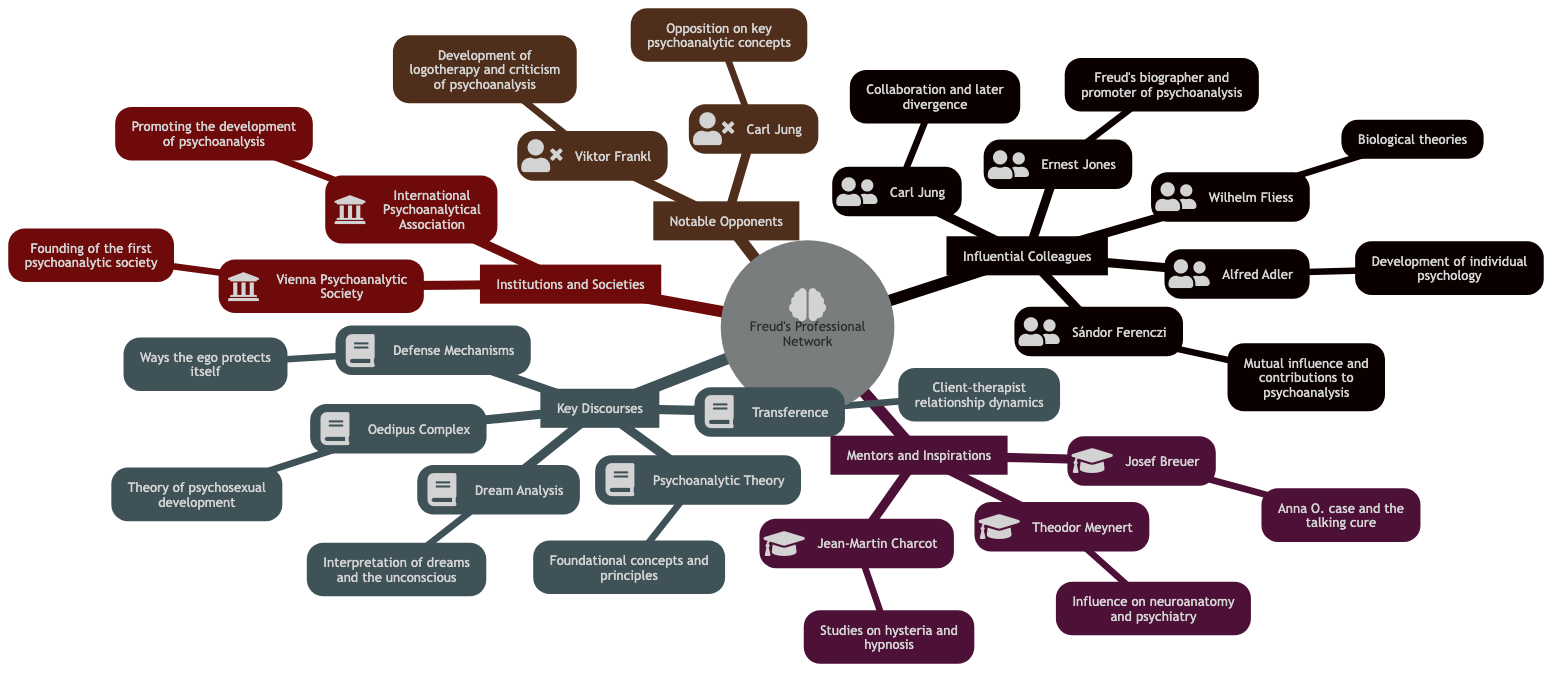What are the main topics in Freud's Professional Network? The main topics in the mind map are "Influential Colleagues," "Mentors and Inspirations," "Key Discourses," "Notable Opponents," and "Institutions and Societies." Each of these subtopics is connected to Freud's professional life, highlighting different aspects of his network.
Answer: Influential Colleagues, Mentors and Inspirations, Key Discourses, Notable Opponents, Institutions and Societies Who is described as Freud's biographer and promoter of psychoanalysis? In the "Influential Colleagues" section, the element describing Freud's biographer and promoter is Ernest Jones, which clearly states this role in the context provided.
Answer: Ernest Jones How many mentors are listed in Freud's Professional Network? Counting the elements in the "Mentors and Inspirations" section, there are three notable figures mentioned: Jean-Martin Charcot, Josef Breuer, and Theodor Meynert. Summing these gives a total count of three mentors.
Answer: 3 What significant theory is associated with Freud related to psychosexual development? The "Key Discourses" segment includes the "Oedipus Complex," which Freud developed as a central theory regarding psychosexual development. The specific focus on this theory confirms its significance in his work.
Answer: Oedipus Complex Which two individuals are cited as notable opponents of Freud? In the "Notable Opponents" section, both Carl Jung and Viktor Frankl are explicitly mentioned as significant figures who opposed Freud’s psychoanalytic concepts. Gathering these names provides a clear answer.
Answer: Carl Jung, Viktor Frankl Which institution is known for being the first psychoanalytic society? The "Institutions and Societies" section identifies the "Vienna Psychoanalytic Society" as the founding institution of the first psychoanalytic society, making it a key part of Freud's professional network.
Answer: Vienna Psychoanalytic Society What are two key elements discussed under "Key Discourses"? From the "Key Discourses" section, two elements that can be directly referenced are "Dream Analysis" and "Defense Mechanisms," both of which are foundational aspects of Freud's theories. This observation confirms the presence of these two topics.
Answer: Dream Analysis, Defense Mechanisms Who collaborated with Freud but later diverged in their views? The element detailing this relationship in the "Influential Colleagues" area explicitly identifies Carl Jung as the figure who collaborated with Freud and eventually diverged from his views, establishing this notable shift within his professional network.
Answer: Carl Jung What significant study is associated with Josef Breuer? The mind map indicates that Josef Breuer is associated with the "Anna O. case and the talking cure," which showcases his significant contribution to the development of psychoanalysis alongside Freud.
Answer: Anna O. case and the talking cure 